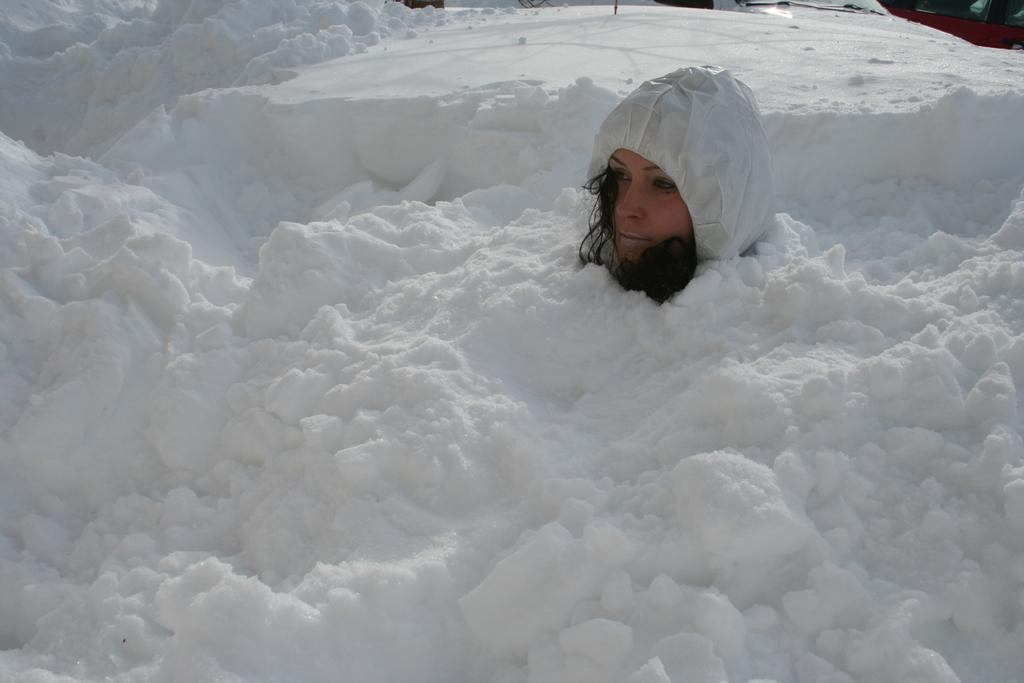Who is present in the image? There is a woman in the image. What is the woman doing in the image? The woman is sitting in the image. What is the environment like in the image? The ground is covered with snow, and the woman is under the snow. What is the woman wearing in the image? The woman is wearing a hoodie in the image. Where is the playground located in the image? There is no playground present in the image. What is the woman doing to her throat in the image? The woman is not doing anything to her throat in the image; she is simply sitting under the snow. 